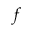<formula> <loc_0><loc_0><loc_500><loc_500>f</formula> 